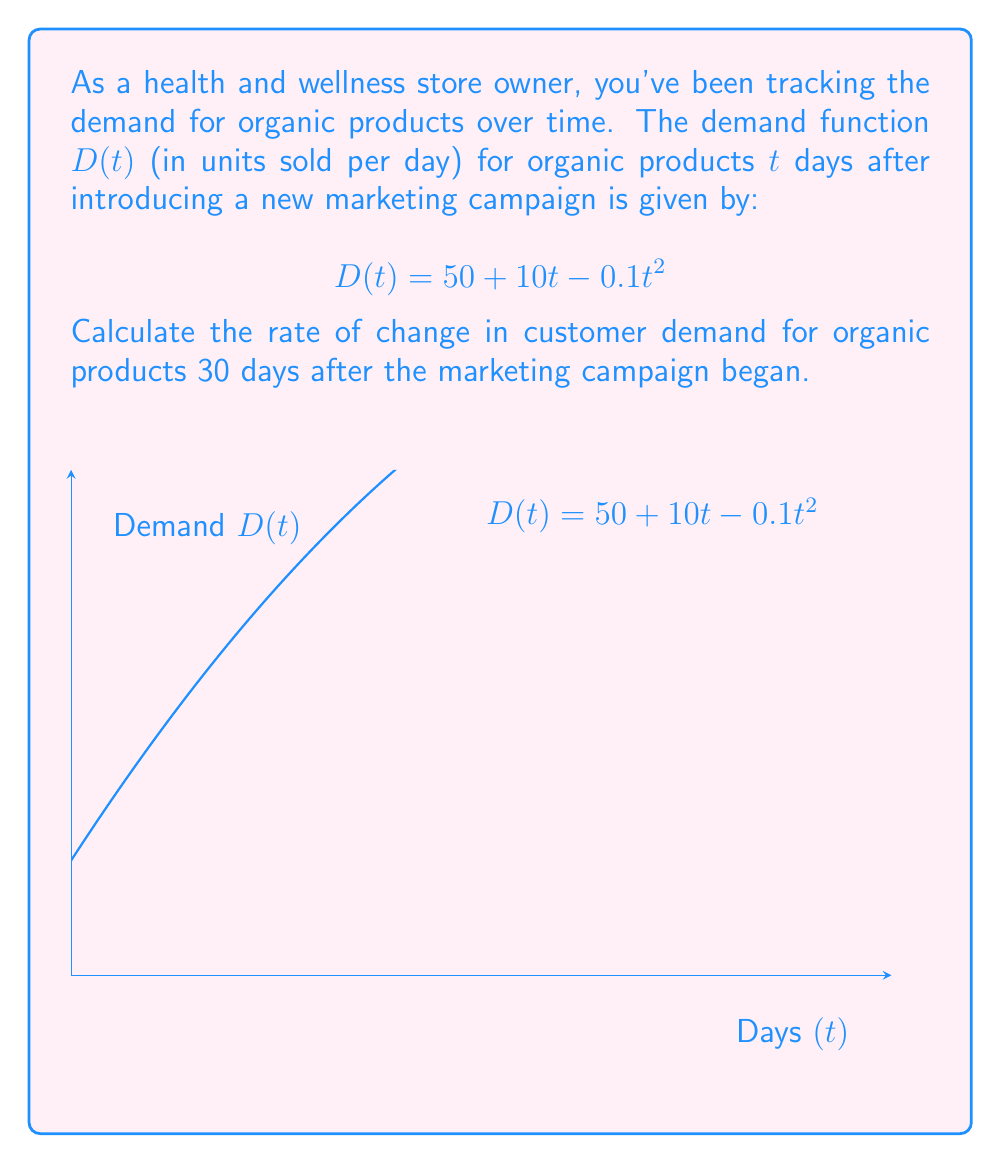Teach me how to tackle this problem. To find the rate of change in customer demand, we need to calculate the derivative of the demand function $D(t)$ and evaluate it at $t = 30$. Let's follow these steps:

1) The demand function is given as:
   $$D(t) = 50 + 10t - 0.1t^2$$

2) To find the rate of change, we need to differentiate $D(t)$ with respect to $t$:
   $$\frac{d}{dt}D(t) = \frac{d}{dt}(50 + 10t - 0.1t^2)$$

3) Using the power rule and constant rule of differentiation:
   $$\frac{d}{dt}D(t) = 0 + 10 - 0.1(2t)$$
   $$\frac{d}{dt}D(t) = 10 - 0.2t$$

4) This derivative represents the instantaneous rate of change of demand with respect to time.

5) To find the rate of change at $t = 30$ days, we substitute $t = 30$ into our derivative:
   $$\frac{d}{dt}D(30) = 10 - 0.2(30)$$
   $$\frac{d}{dt}D(30) = 10 - 6 = 4$$

Therefore, 30 days after the marketing campaign began, the rate of change in customer demand for organic products is 4 units per day.
Answer: $4$ units/day 